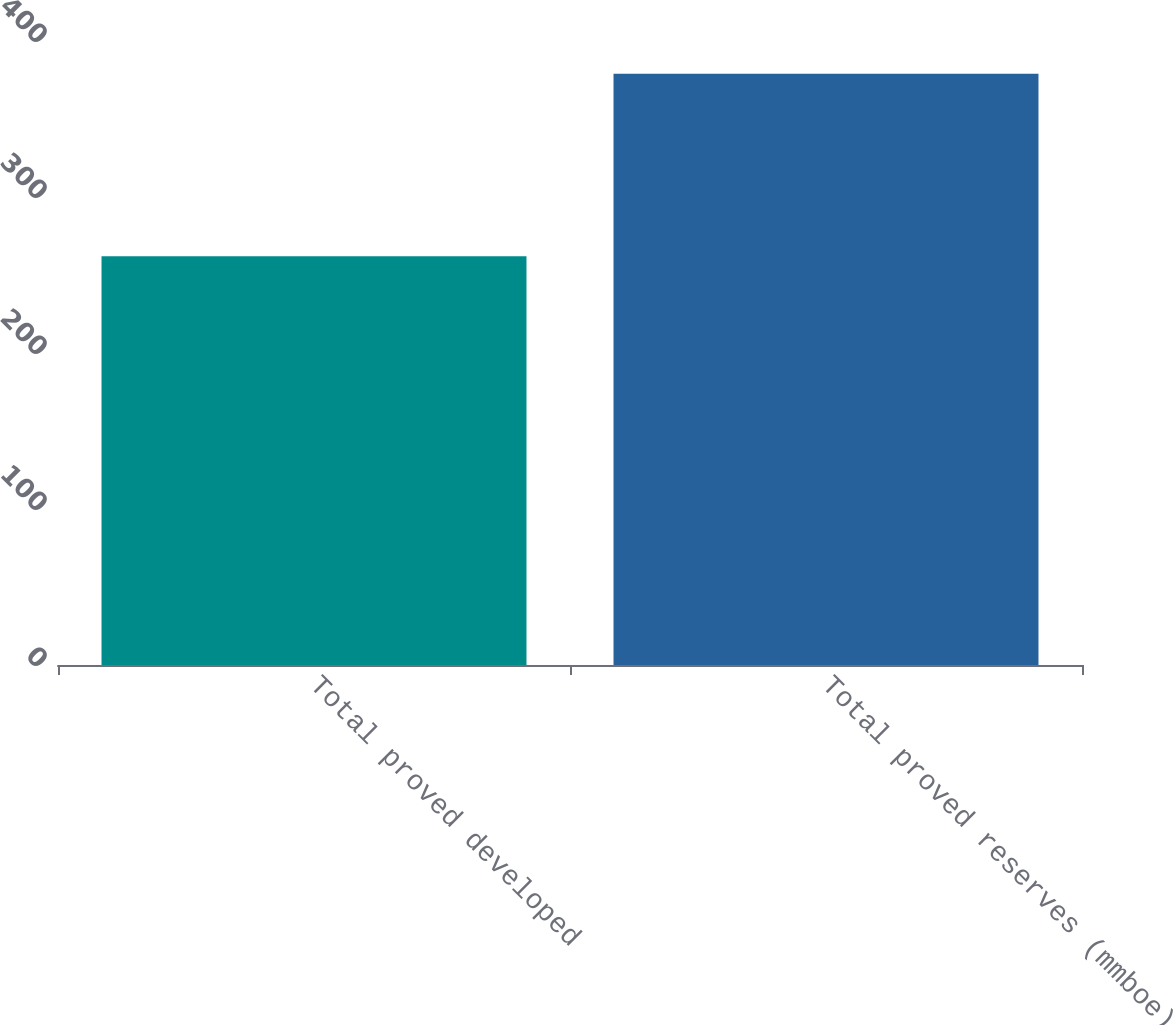Convert chart. <chart><loc_0><loc_0><loc_500><loc_500><bar_chart><fcel>Total proved developed<fcel>Total proved reserves (mmboe)<nl><fcel>262<fcel>379<nl></chart> 